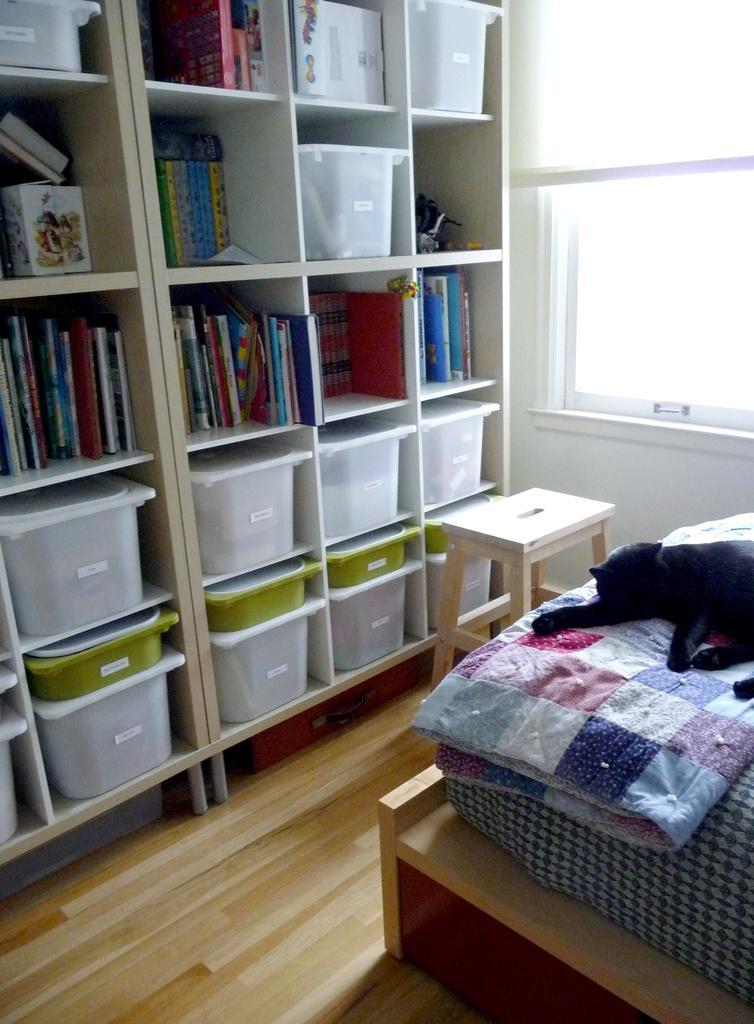How would you summarize this image in a sentence or two? This is looking like a room. In this room there is a cot and on the cot there is a bed. A cat is laying on this bed. There is a stool on the corner of this room. There is a window in this wall. There is a big cupboard. In this cupboard there are some books, some boxes are there. 